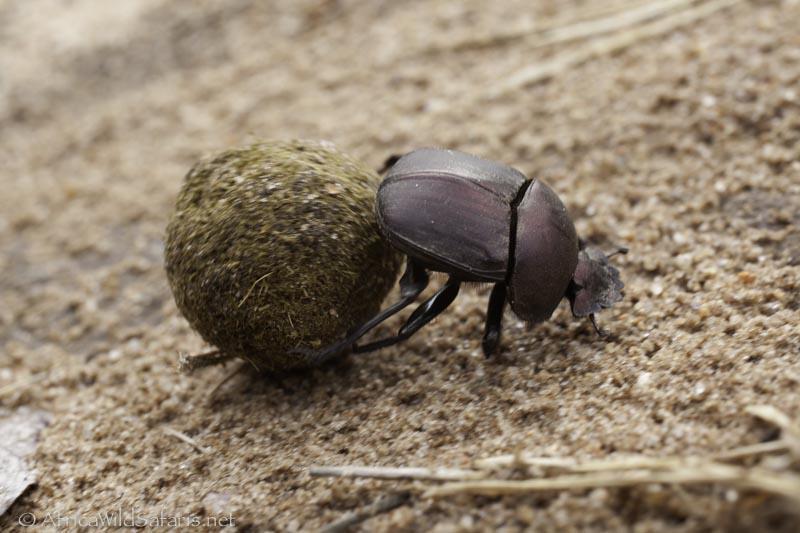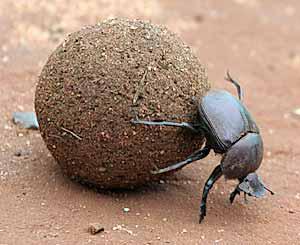The first image is the image on the left, the second image is the image on the right. Given the left and right images, does the statement "There are two beetles near a clod of dirt in one of the images." hold true? Answer yes or no. No. The first image is the image on the left, the second image is the image on the right. For the images shown, is this caption "An image includes two beetles, with at least one beetle in contact with a round dungball." true? Answer yes or no. No. 